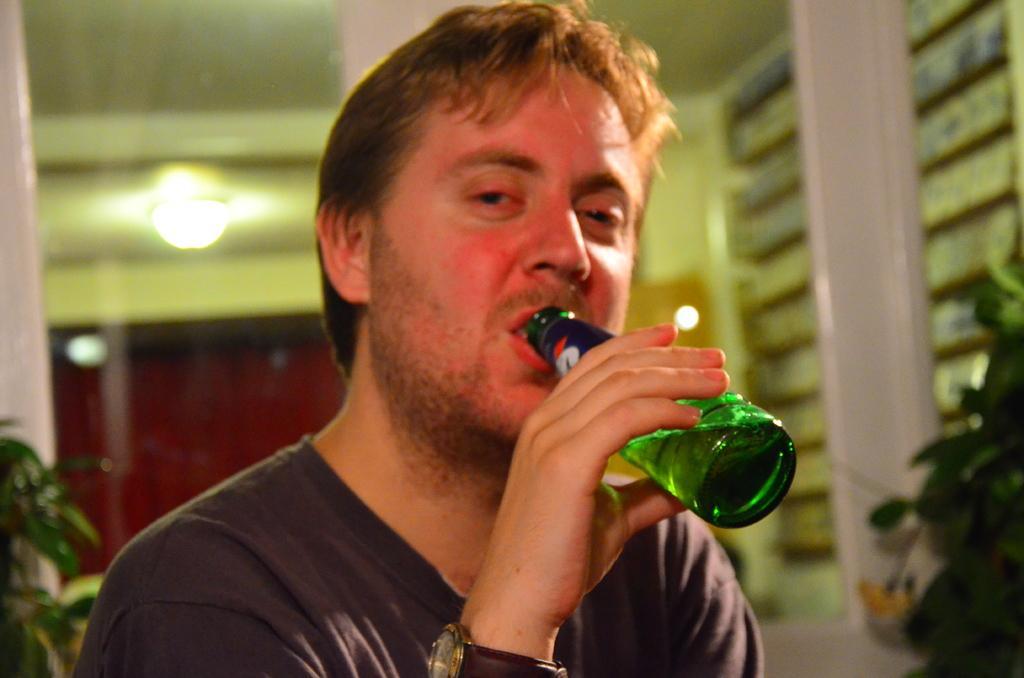Describe this image in one or two sentences. In this image I can see a person holding green color bottle. Back I can see a light,windows,building and trees. 